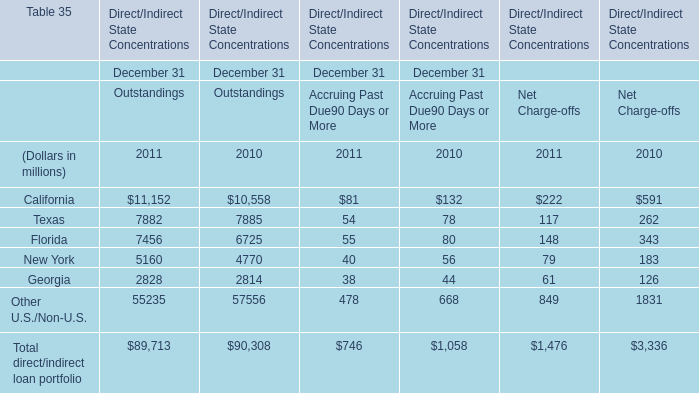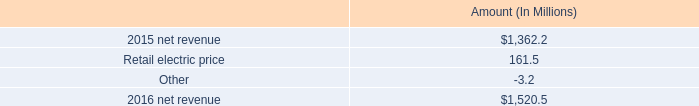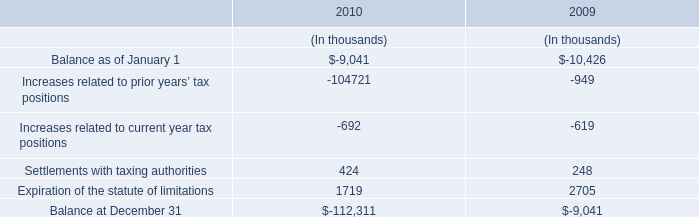What's the total amount of the California in the years where Settlements with taxing authorities is greater than 400? (in million) 
Computations: ((10558 + 132) + 591)
Answer: 11281.0. 